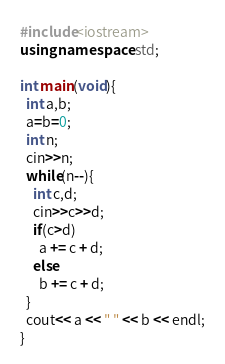<code> <loc_0><loc_0><loc_500><loc_500><_C++_>#include<iostream>
using namespace std;

int main(void){
  int a,b;
  a=b=0;
  int n;
  cin>>n;
  while(n--){
    int c,d;
    cin>>c>>d;
    if(c>d)
      a += c + d;
    else
      b += c + d; 
  }
  cout<< a << " " << b << endl;
}</code> 